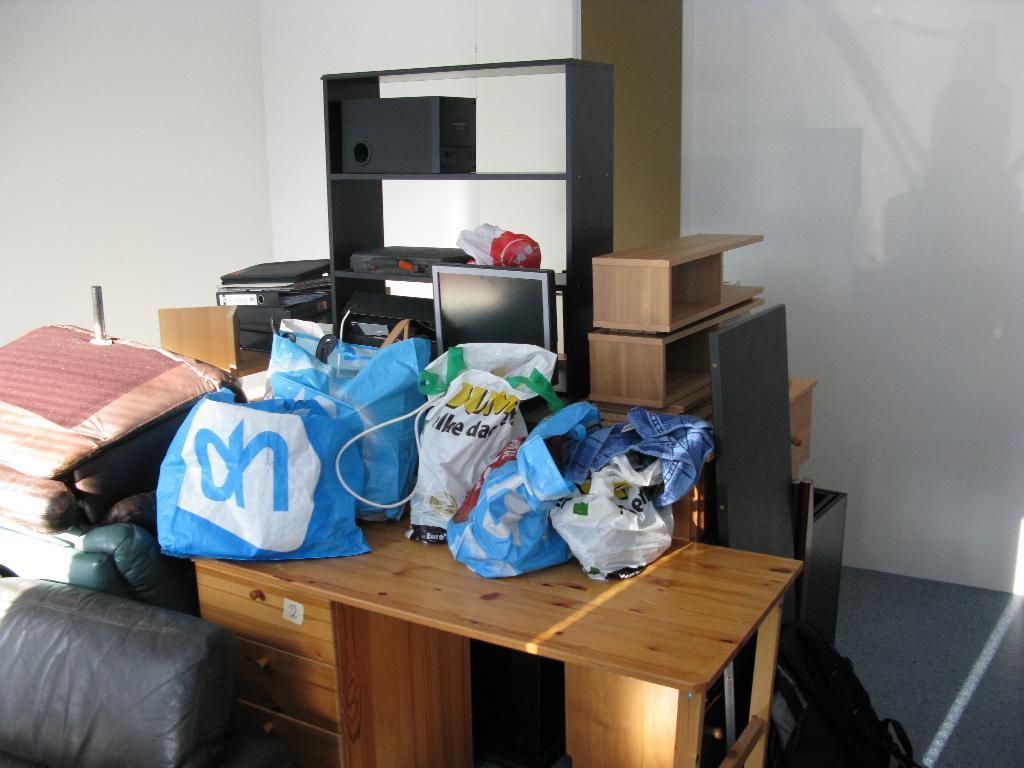Provide a one-sentence caption for the provided image. A messy room with bags all over a desk, one of which says OH. 